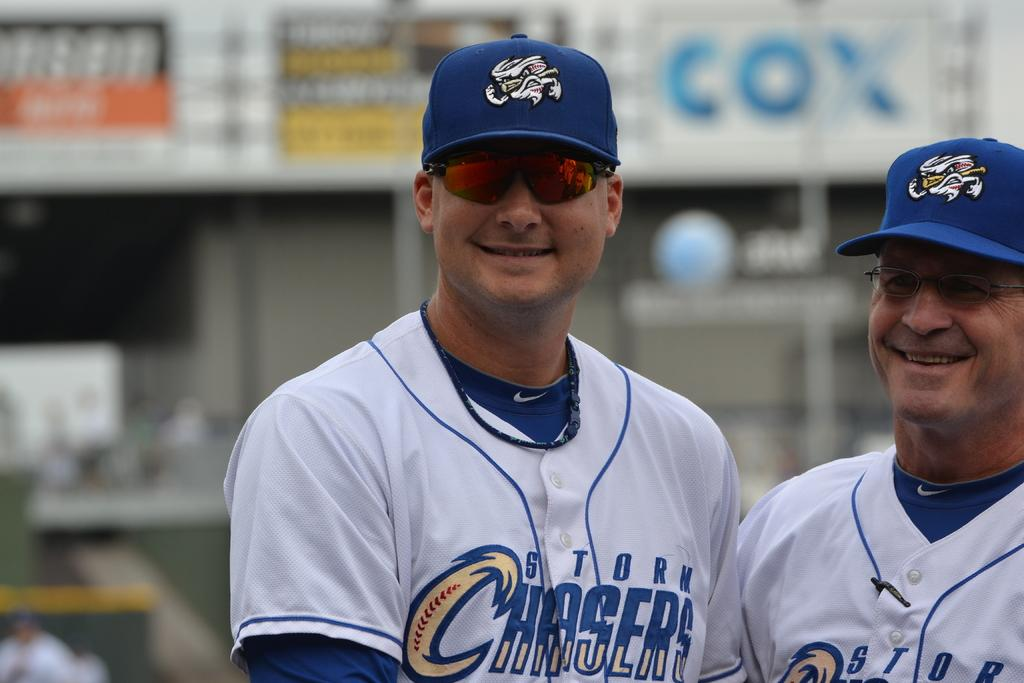<image>
Create a compact narrative representing the image presented. A pair of baseball players from the Storm Chasers smiling. 